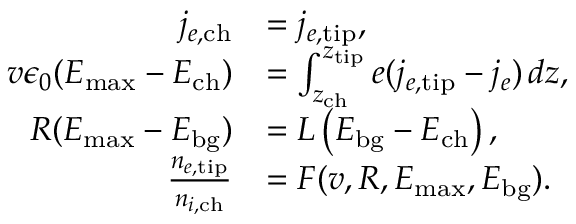<formula> <loc_0><loc_0><loc_500><loc_500>\begin{array} { r l } { j _ { e , c h } } & { = j _ { e , t i p } , } \\ { v \epsilon _ { 0 } ( E _ { \max } - E _ { c h } ) } & { = \int _ { z _ { c h } } ^ { z _ { t i p } } e ( j _ { e , t i p } - j _ { e } ) \, d z , } \\ { R ( E _ { \max } - E _ { b g } ) } & { = L \left ( E _ { b g } - E _ { c h } \right ) , } \\ { \frac { n _ { e , t i p } } { n _ { i , c h } } } & { = F ( v , R , E _ { \max } , E _ { b g } ) . } \end{array}</formula> 